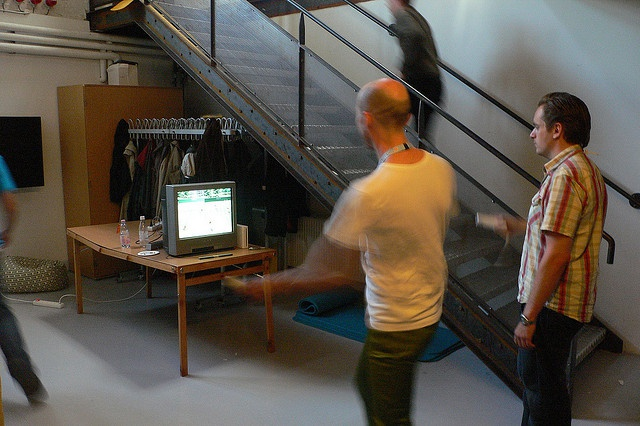Describe the objects in this image and their specific colors. I can see people in gray, black, olive, and maroon tones, people in gray, black, maroon, and olive tones, tv in gray, white, and black tones, people in gray and black tones, and people in gray, black, and maroon tones in this image. 